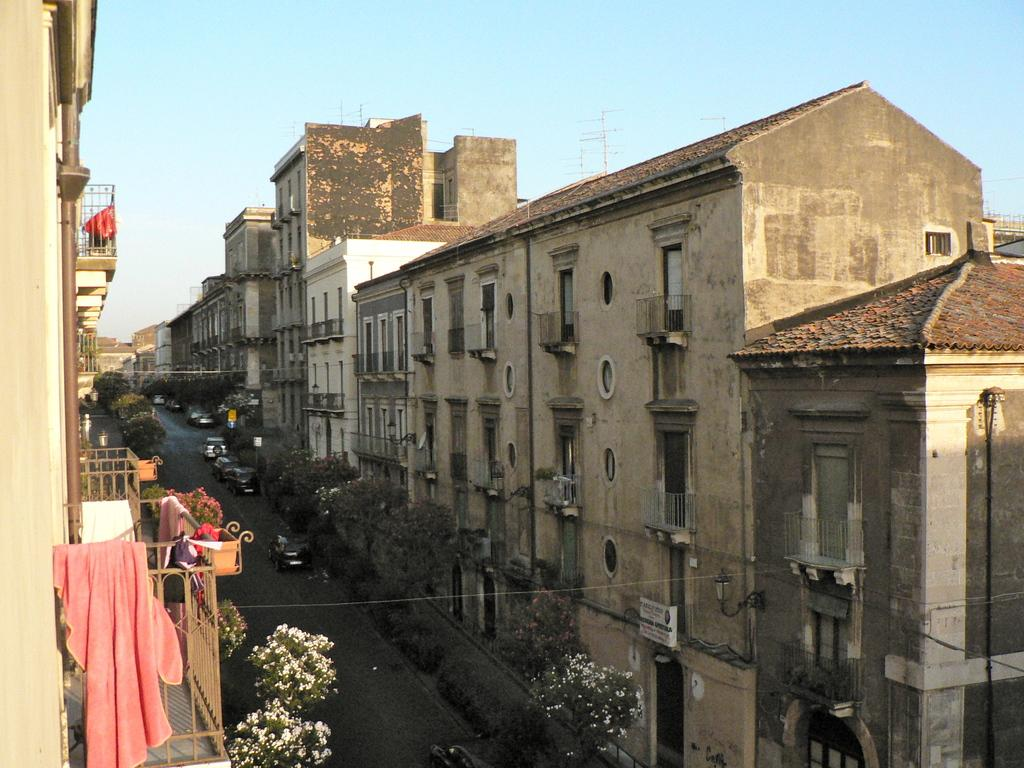What is the main feature of the image? There is a road in the image. What can be seen on the road? There are vehicles on the road. What type of vegetation is present in the image? There are trees and flowers in the image. What type of structures are visible in the image? There are buildings on both sides of the road. What is visible in the background of the image? The sky is visible in the background of the image. What type of straw is being used to build the buildings in the image? There is no straw present in the image; the buildings are made of other materials. Can you see any islands in the image? There are no islands present in the image; it features a road, vehicles, trees, flowers, buildings, and the sky. 